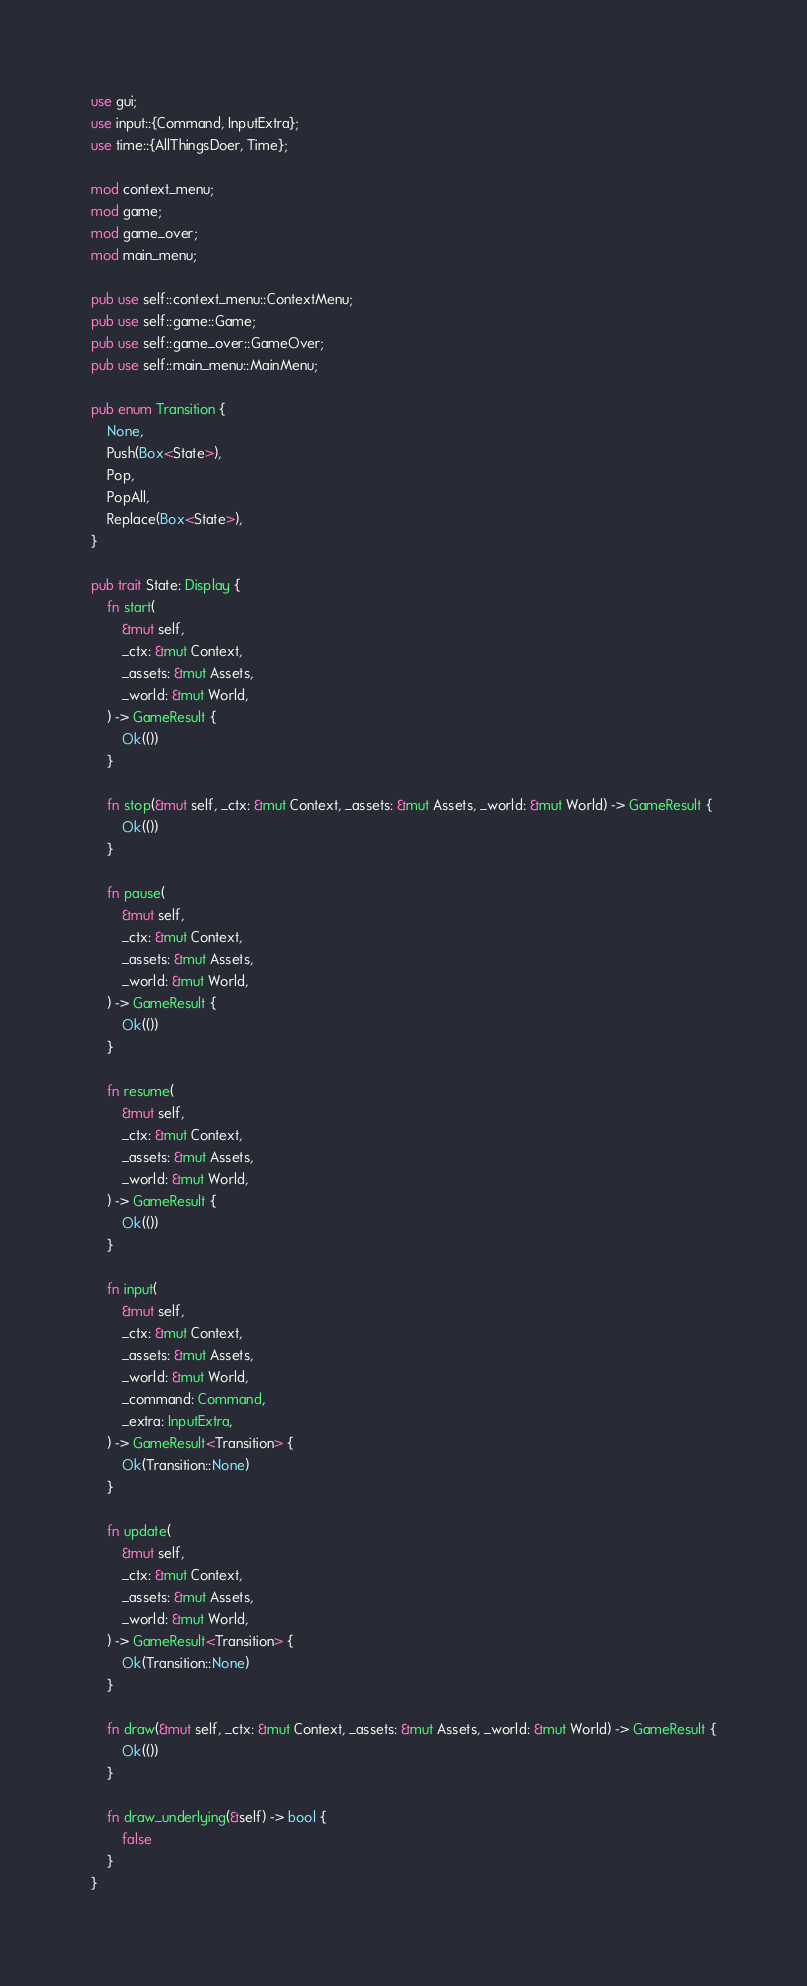<code> <loc_0><loc_0><loc_500><loc_500><_Rust_>use gui;
use input::{Command, InputExtra};
use time::{AllThingsDoer, Time};

mod context_menu;
mod game;
mod game_over;
mod main_menu;

pub use self::context_menu::ContextMenu;
pub use self::game::Game;
pub use self::game_over::GameOver;
pub use self::main_menu::MainMenu;

pub enum Transition {
    None,
    Push(Box<State>),
    Pop,
    PopAll,
    Replace(Box<State>),
}

pub trait State: Display {
    fn start(
        &mut self,
        _ctx: &mut Context,
        _assets: &mut Assets,
        _world: &mut World,
    ) -> GameResult {
        Ok(())
    }

    fn stop(&mut self, _ctx: &mut Context, _assets: &mut Assets, _world: &mut World) -> GameResult {
        Ok(())
    }

    fn pause(
        &mut self,
        _ctx: &mut Context,
        _assets: &mut Assets,
        _world: &mut World,
    ) -> GameResult {
        Ok(())
    }

    fn resume(
        &mut self,
        _ctx: &mut Context,
        _assets: &mut Assets,
        _world: &mut World,
    ) -> GameResult {
        Ok(())
    }

    fn input(
        &mut self,
        _ctx: &mut Context,
        _assets: &mut Assets,
        _world: &mut World,
        _command: Command,
        _extra: InputExtra,
    ) -> GameResult<Transition> {
        Ok(Transition::None)
    }

    fn update(
        &mut self,
        _ctx: &mut Context,
        _assets: &mut Assets,
        _world: &mut World,
    ) -> GameResult<Transition> {
        Ok(Transition::None)
    }

    fn draw(&mut self, _ctx: &mut Context, _assets: &mut Assets, _world: &mut World) -> GameResult {
        Ok(())
    }

    fn draw_underlying(&self) -> bool {
        false
    }
}
</code> 